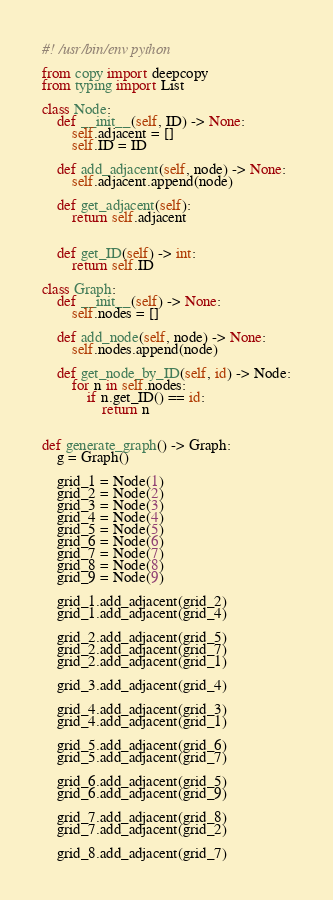<code> <loc_0><loc_0><loc_500><loc_500><_Python_>#! /usr/bin/env python

from copy import deepcopy
from typing import List

class Node:
    def __init__(self, ID) -> None:
        self.adjacent = []
        self.ID = ID

    def add_adjacent(self, node) -> None:
        self.adjacent.append(node)
    
    def get_adjacent(self):
        return self.adjacent

    
    def get_ID(self) -> int:
        return self.ID

class Graph:
    def __init__(self) -> None:
        self.nodes = []

    def add_node(self, node) -> None:
        self.nodes.append(node)

    def get_node_by_ID(self, id) -> Node:
        for n in self.nodes:
            if n.get_ID() == id:
                return n


def generate_graph() -> Graph:
    g = Graph()

    grid_1 = Node(1)
    grid_2 = Node(2)
    grid_3 = Node(3)
    grid_4 = Node(4)
    grid_5 = Node(5)
    grid_6 = Node(6)
    grid_7 = Node(7)
    grid_8 = Node(8)
    grid_9 = Node(9)

    grid_1.add_adjacent(grid_2)
    grid_1.add_adjacent(grid_4)

    grid_2.add_adjacent(grid_5)
    grid_2.add_adjacent(grid_7)
    grid_2.add_adjacent(grid_1)

    grid_3.add_adjacent(grid_4)

    grid_4.add_adjacent(grid_3)
    grid_4.add_adjacent(grid_1)

    grid_5.add_adjacent(grid_6)
    grid_5.add_adjacent(grid_7)

    grid_6.add_adjacent(grid_5)
    grid_6.add_adjacent(grid_9)

    grid_7.add_adjacent(grid_8)
    grid_7.add_adjacent(grid_2)

    grid_8.add_adjacent(grid_7)
</code> 